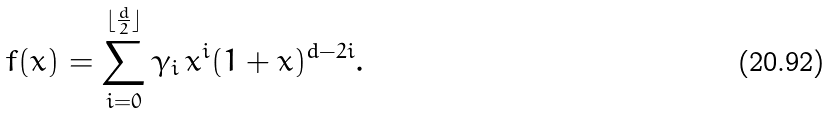Convert formula to latex. <formula><loc_0><loc_0><loc_500><loc_500>f ( x ) = \sum _ { i = 0 } ^ { \lfloor \frac { d } { 2 } \rfloor } \gamma _ { i } \, x ^ { i } ( 1 + x ) ^ { d - 2 i } .</formula> 